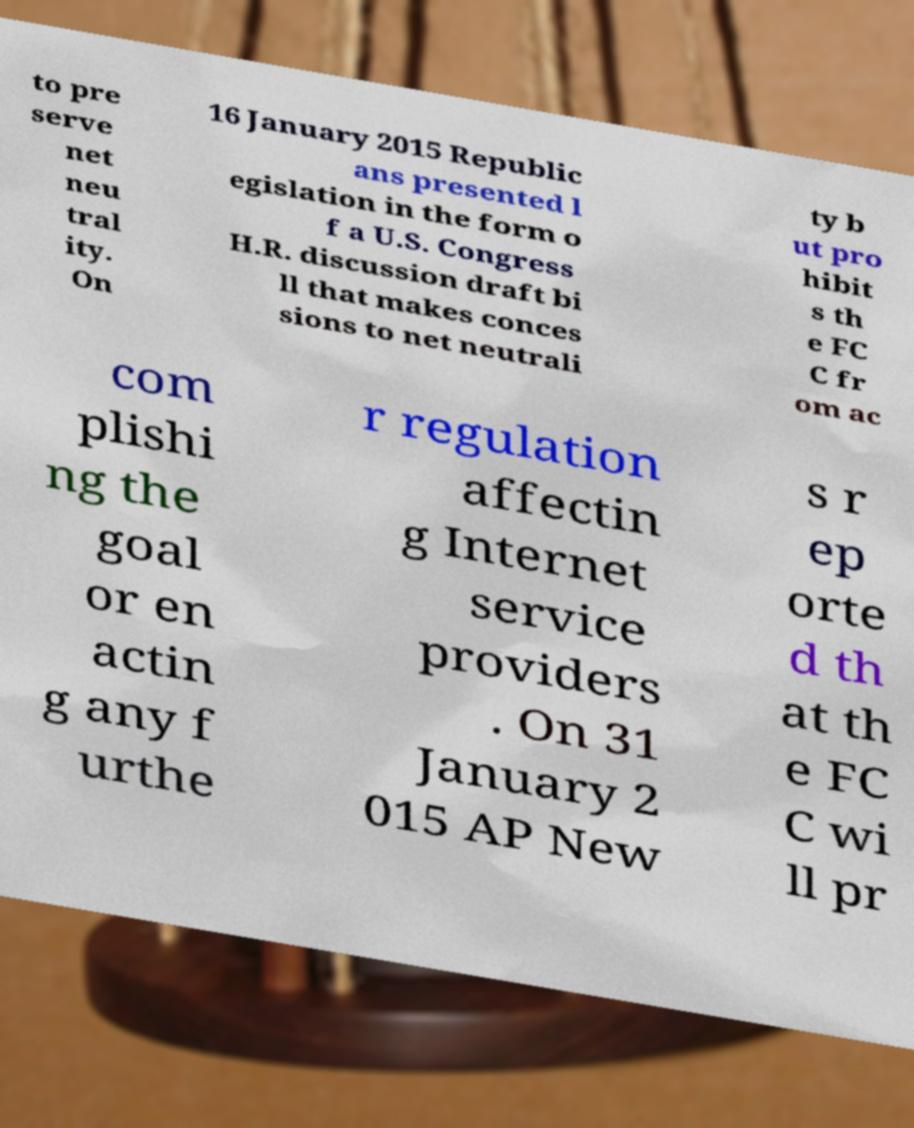Can you read and provide the text displayed in the image?This photo seems to have some interesting text. Can you extract and type it out for me? to pre serve net neu tral ity. On 16 January 2015 Republic ans presented l egislation in the form o f a U.S. Congress H.R. discussion draft bi ll that makes conces sions to net neutrali ty b ut pro hibit s th e FC C fr om ac com plishi ng the goal or en actin g any f urthe r regulation affectin g Internet service providers . On 31 January 2 015 AP New s r ep orte d th at th e FC C wi ll pr 